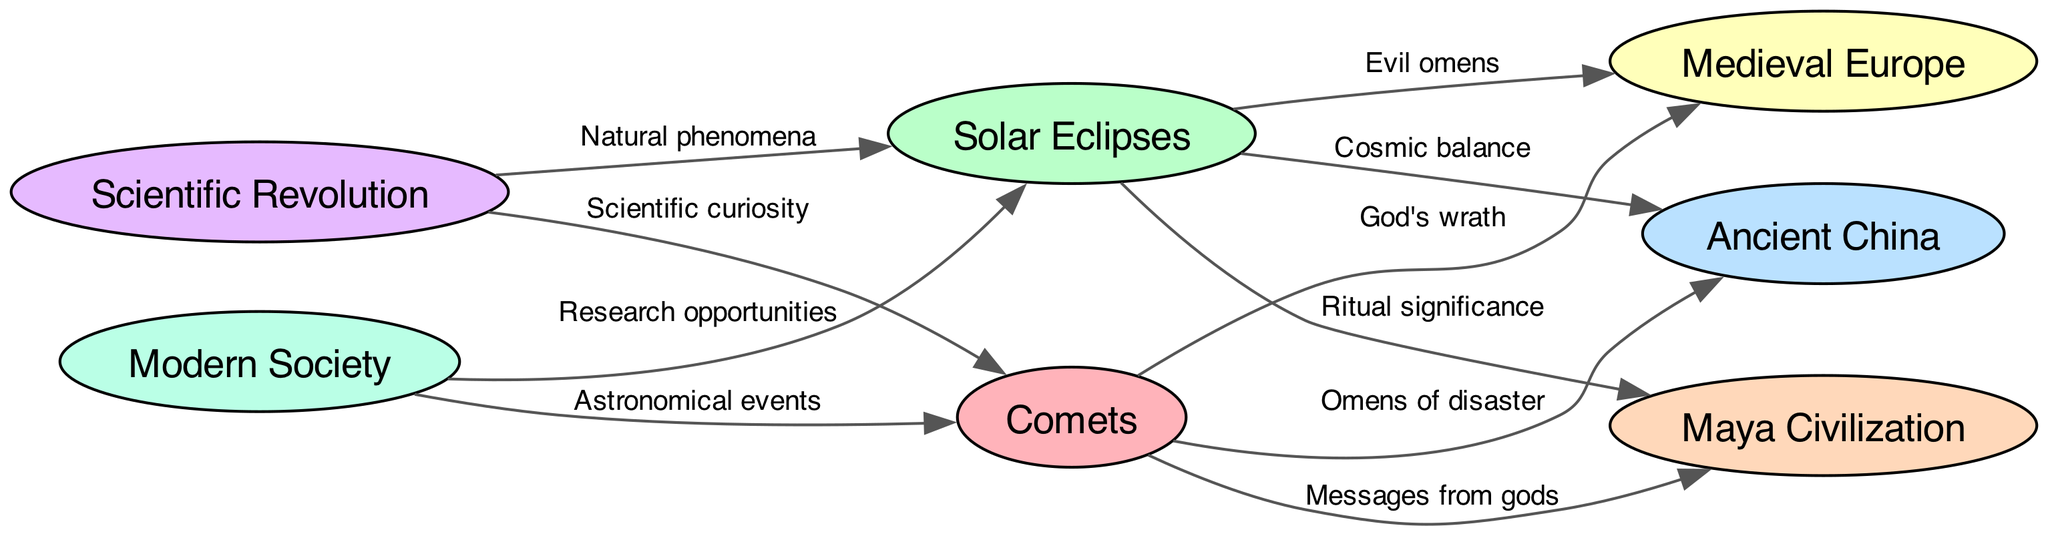What are the two celestial events depicted in the diagram? The diagram shows comets and solar eclipses as the main celestial events. This information can be gathered by looking at the two nodes at the top of the diagram labeled accordingly.
Answer: Comets, solar eclipses How many cultures are represented in this diagram? The diagram illustrates four distinct cultures: Ancient China, Medieval Europe, Maya Civilization, and Modern Society. This can be determined by counting the unique cultural nodes connected to the celestial events.
Answer: Four What relationship do comets have with Medieval Europe? According to the diagram, comets are perceived as symbols of God's wrath in Medieval Europe, which is found by tracing the edge from comets to Medieval Europe labeled as such.
Answer: God's wrath What is the significance of solar eclipses in the Maya Civilization? The diagram indicates that solar eclipses hold ritual significance for the Maya Civilization, as noted by the directed edge from solar eclipses to the Maya Civilization with that label.
Answer: Ritual significance What did the Scientific Revolution bring to the understanding of comets? The diagram connects the Scientific Revolution to comets with the label scientific curiosity, indicating that this period expanded interest and inquiry into comets.
Answer: Scientific curiosity How do comets impact Ancient China according to the diagram? In Ancient China, comets are viewed as omens of disaster, shown by the directed edge from comets to Ancient China, indicating their significance as foretellers of misfortune.
Answer: Omens of disaster What is the relationship between solar eclipses and research opportunities in modern society? The edge in the diagram shows that solar eclipses present research opportunities in modern society, which highlights a shift from superstition to scientific inquiry in this context.
Answer: Research opportunities What label connects solar eclipses to Medieval Europe? The relationship between solar eclipses and Medieval Europe is represented by the label evil omens, indicating how such events were interpreted negatively during that time period.
Answer: Evil omens What cultural belief is associated with comets in the Maya Civilization? The diagram connects the Maya Civilization to comets with the label messages from gods, indicating a belief that comets represented divine communication.
Answer: Messages from gods 